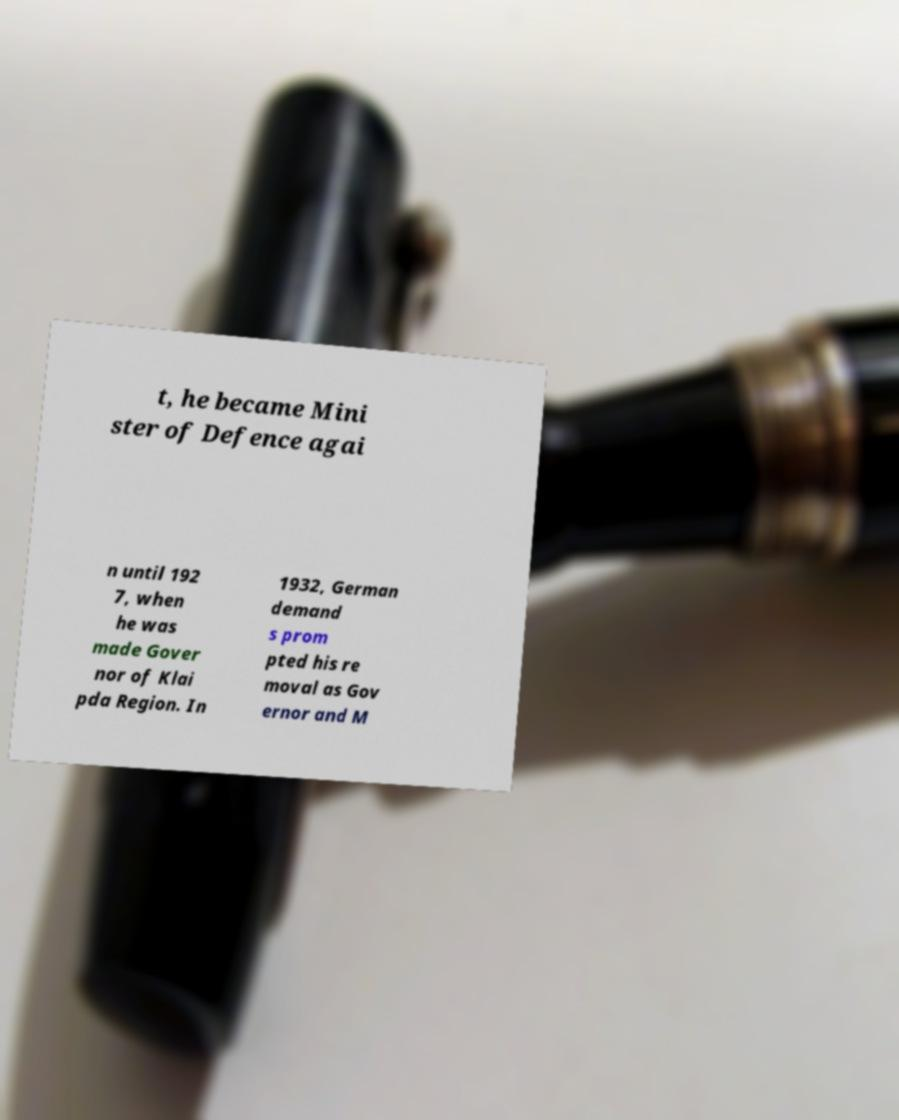Could you extract and type out the text from this image? t, he became Mini ster of Defence agai n until 192 7, when he was made Gover nor of Klai pda Region. In 1932, German demand s prom pted his re moval as Gov ernor and M 